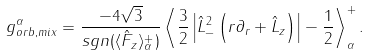<formula> <loc_0><loc_0><loc_500><loc_500>g _ { o r b , m i x } ^ { \alpha } = \frac { - 4 \sqrt { 3 } } { s g n ( \langle \hat { F } _ { z } \rangle ^ { + } _ { \alpha } ) } \left \langle \frac { 3 } { 2 } \left | \hat { L } _ { - } ^ { 2 } \left ( r \partial _ { r } + \hat { L } _ { z } \right ) \right | - \frac { 1 } { 2 } \right \rangle _ { \alpha } ^ { + } .</formula> 